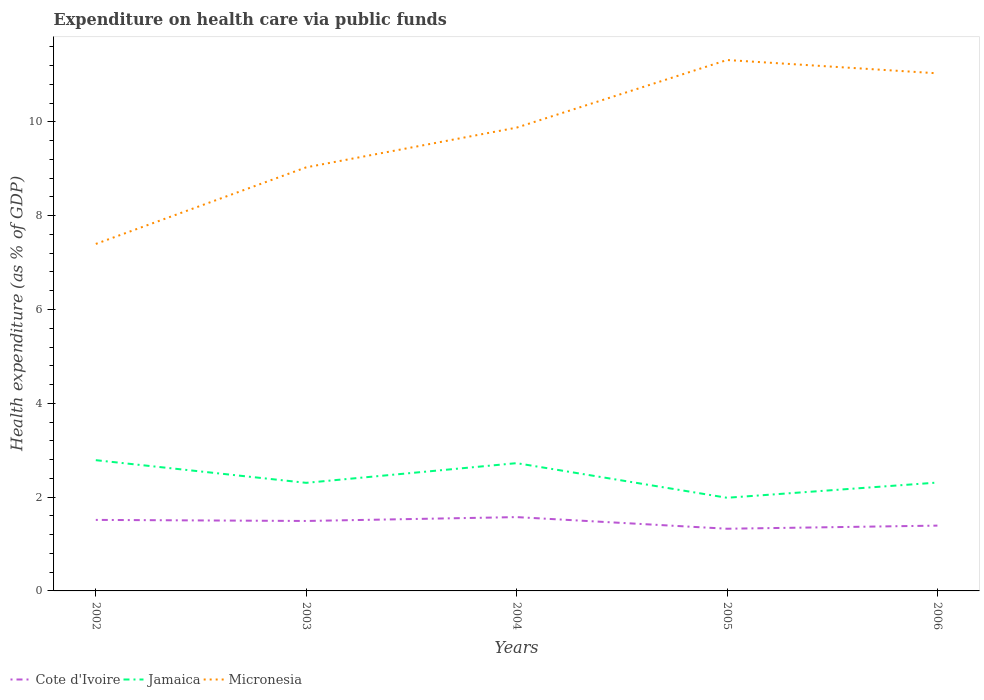Does the line corresponding to Micronesia intersect with the line corresponding to Cote d'Ivoire?
Make the answer very short. No. Across all years, what is the maximum expenditure made on health care in Jamaica?
Provide a succinct answer. 1.99. What is the total expenditure made on health care in Micronesia in the graph?
Give a very brief answer. -2. What is the difference between the highest and the second highest expenditure made on health care in Jamaica?
Give a very brief answer. 0.8. What is the difference between the highest and the lowest expenditure made on health care in Jamaica?
Give a very brief answer. 2. What is the difference between two consecutive major ticks on the Y-axis?
Keep it short and to the point. 2. Where does the legend appear in the graph?
Offer a terse response. Bottom left. What is the title of the graph?
Keep it short and to the point. Expenditure on health care via public funds. What is the label or title of the Y-axis?
Provide a short and direct response. Health expenditure (as % of GDP). What is the Health expenditure (as % of GDP) in Cote d'Ivoire in 2002?
Give a very brief answer. 1.51. What is the Health expenditure (as % of GDP) in Jamaica in 2002?
Give a very brief answer. 2.79. What is the Health expenditure (as % of GDP) in Micronesia in 2002?
Offer a very short reply. 7.4. What is the Health expenditure (as % of GDP) of Cote d'Ivoire in 2003?
Offer a terse response. 1.49. What is the Health expenditure (as % of GDP) of Jamaica in 2003?
Make the answer very short. 2.3. What is the Health expenditure (as % of GDP) in Micronesia in 2003?
Ensure brevity in your answer.  9.03. What is the Health expenditure (as % of GDP) of Cote d'Ivoire in 2004?
Provide a succinct answer. 1.57. What is the Health expenditure (as % of GDP) in Jamaica in 2004?
Give a very brief answer. 2.72. What is the Health expenditure (as % of GDP) in Micronesia in 2004?
Offer a very short reply. 9.88. What is the Health expenditure (as % of GDP) of Cote d'Ivoire in 2005?
Provide a succinct answer. 1.33. What is the Health expenditure (as % of GDP) in Jamaica in 2005?
Make the answer very short. 1.99. What is the Health expenditure (as % of GDP) in Micronesia in 2005?
Give a very brief answer. 11.32. What is the Health expenditure (as % of GDP) in Cote d'Ivoire in 2006?
Provide a succinct answer. 1.39. What is the Health expenditure (as % of GDP) of Jamaica in 2006?
Provide a short and direct response. 2.31. What is the Health expenditure (as % of GDP) in Micronesia in 2006?
Offer a terse response. 11.03. Across all years, what is the maximum Health expenditure (as % of GDP) in Cote d'Ivoire?
Give a very brief answer. 1.57. Across all years, what is the maximum Health expenditure (as % of GDP) of Jamaica?
Your response must be concise. 2.79. Across all years, what is the maximum Health expenditure (as % of GDP) in Micronesia?
Offer a terse response. 11.32. Across all years, what is the minimum Health expenditure (as % of GDP) in Cote d'Ivoire?
Keep it short and to the point. 1.33. Across all years, what is the minimum Health expenditure (as % of GDP) in Jamaica?
Give a very brief answer. 1.99. Across all years, what is the minimum Health expenditure (as % of GDP) of Micronesia?
Make the answer very short. 7.4. What is the total Health expenditure (as % of GDP) in Cote d'Ivoire in the graph?
Provide a short and direct response. 7.3. What is the total Health expenditure (as % of GDP) in Jamaica in the graph?
Your answer should be compact. 12.11. What is the total Health expenditure (as % of GDP) in Micronesia in the graph?
Keep it short and to the point. 48.66. What is the difference between the Health expenditure (as % of GDP) in Cote d'Ivoire in 2002 and that in 2003?
Keep it short and to the point. 0.02. What is the difference between the Health expenditure (as % of GDP) of Jamaica in 2002 and that in 2003?
Provide a short and direct response. 0.48. What is the difference between the Health expenditure (as % of GDP) of Micronesia in 2002 and that in 2003?
Ensure brevity in your answer.  -1.63. What is the difference between the Health expenditure (as % of GDP) in Cote d'Ivoire in 2002 and that in 2004?
Keep it short and to the point. -0.06. What is the difference between the Health expenditure (as % of GDP) of Jamaica in 2002 and that in 2004?
Provide a succinct answer. 0.06. What is the difference between the Health expenditure (as % of GDP) in Micronesia in 2002 and that in 2004?
Offer a very short reply. -2.48. What is the difference between the Health expenditure (as % of GDP) in Cote d'Ivoire in 2002 and that in 2005?
Your response must be concise. 0.19. What is the difference between the Health expenditure (as % of GDP) in Jamaica in 2002 and that in 2005?
Offer a very short reply. 0.8. What is the difference between the Health expenditure (as % of GDP) of Micronesia in 2002 and that in 2005?
Offer a very short reply. -3.92. What is the difference between the Health expenditure (as % of GDP) in Cote d'Ivoire in 2002 and that in 2006?
Make the answer very short. 0.12. What is the difference between the Health expenditure (as % of GDP) in Jamaica in 2002 and that in 2006?
Your answer should be very brief. 0.48. What is the difference between the Health expenditure (as % of GDP) of Micronesia in 2002 and that in 2006?
Offer a terse response. -3.64. What is the difference between the Health expenditure (as % of GDP) in Cote d'Ivoire in 2003 and that in 2004?
Keep it short and to the point. -0.08. What is the difference between the Health expenditure (as % of GDP) in Jamaica in 2003 and that in 2004?
Give a very brief answer. -0.42. What is the difference between the Health expenditure (as % of GDP) of Micronesia in 2003 and that in 2004?
Your answer should be very brief. -0.85. What is the difference between the Health expenditure (as % of GDP) in Cote d'Ivoire in 2003 and that in 2005?
Offer a terse response. 0.17. What is the difference between the Health expenditure (as % of GDP) in Jamaica in 2003 and that in 2005?
Provide a short and direct response. 0.32. What is the difference between the Health expenditure (as % of GDP) in Micronesia in 2003 and that in 2005?
Provide a succinct answer. -2.29. What is the difference between the Health expenditure (as % of GDP) in Cote d'Ivoire in 2003 and that in 2006?
Keep it short and to the point. 0.1. What is the difference between the Health expenditure (as % of GDP) in Jamaica in 2003 and that in 2006?
Keep it short and to the point. -0.01. What is the difference between the Health expenditure (as % of GDP) in Micronesia in 2003 and that in 2006?
Keep it short and to the point. -2. What is the difference between the Health expenditure (as % of GDP) in Cote d'Ivoire in 2004 and that in 2005?
Provide a succinct answer. 0.25. What is the difference between the Health expenditure (as % of GDP) of Jamaica in 2004 and that in 2005?
Make the answer very short. 0.74. What is the difference between the Health expenditure (as % of GDP) of Micronesia in 2004 and that in 2005?
Your response must be concise. -1.44. What is the difference between the Health expenditure (as % of GDP) in Cote d'Ivoire in 2004 and that in 2006?
Give a very brief answer. 0.18. What is the difference between the Health expenditure (as % of GDP) in Jamaica in 2004 and that in 2006?
Ensure brevity in your answer.  0.41. What is the difference between the Health expenditure (as % of GDP) in Micronesia in 2004 and that in 2006?
Offer a very short reply. -1.16. What is the difference between the Health expenditure (as % of GDP) in Cote d'Ivoire in 2005 and that in 2006?
Provide a short and direct response. -0.07. What is the difference between the Health expenditure (as % of GDP) in Jamaica in 2005 and that in 2006?
Give a very brief answer. -0.32. What is the difference between the Health expenditure (as % of GDP) of Micronesia in 2005 and that in 2006?
Provide a short and direct response. 0.28. What is the difference between the Health expenditure (as % of GDP) of Cote d'Ivoire in 2002 and the Health expenditure (as % of GDP) of Jamaica in 2003?
Keep it short and to the point. -0.79. What is the difference between the Health expenditure (as % of GDP) of Cote d'Ivoire in 2002 and the Health expenditure (as % of GDP) of Micronesia in 2003?
Ensure brevity in your answer.  -7.52. What is the difference between the Health expenditure (as % of GDP) in Jamaica in 2002 and the Health expenditure (as % of GDP) in Micronesia in 2003?
Ensure brevity in your answer.  -6.24. What is the difference between the Health expenditure (as % of GDP) of Cote d'Ivoire in 2002 and the Health expenditure (as % of GDP) of Jamaica in 2004?
Offer a very short reply. -1.21. What is the difference between the Health expenditure (as % of GDP) of Cote d'Ivoire in 2002 and the Health expenditure (as % of GDP) of Micronesia in 2004?
Offer a terse response. -8.36. What is the difference between the Health expenditure (as % of GDP) of Jamaica in 2002 and the Health expenditure (as % of GDP) of Micronesia in 2004?
Your response must be concise. -7.09. What is the difference between the Health expenditure (as % of GDP) of Cote d'Ivoire in 2002 and the Health expenditure (as % of GDP) of Jamaica in 2005?
Your answer should be compact. -0.47. What is the difference between the Health expenditure (as % of GDP) in Cote d'Ivoire in 2002 and the Health expenditure (as % of GDP) in Micronesia in 2005?
Provide a succinct answer. -9.8. What is the difference between the Health expenditure (as % of GDP) in Jamaica in 2002 and the Health expenditure (as % of GDP) in Micronesia in 2005?
Provide a short and direct response. -8.53. What is the difference between the Health expenditure (as % of GDP) in Cote d'Ivoire in 2002 and the Health expenditure (as % of GDP) in Jamaica in 2006?
Your answer should be compact. -0.8. What is the difference between the Health expenditure (as % of GDP) in Cote d'Ivoire in 2002 and the Health expenditure (as % of GDP) in Micronesia in 2006?
Provide a succinct answer. -9.52. What is the difference between the Health expenditure (as % of GDP) in Jamaica in 2002 and the Health expenditure (as % of GDP) in Micronesia in 2006?
Your answer should be very brief. -8.25. What is the difference between the Health expenditure (as % of GDP) of Cote d'Ivoire in 2003 and the Health expenditure (as % of GDP) of Jamaica in 2004?
Offer a terse response. -1.23. What is the difference between the Health expenditure (as % of GDP) of Cote d'Ivoire in 2003 and the Health expenditure (as % of GDP) of Micronesia in 2004?
Keep it short and to the point. -8.39. What is the difference between the Health expenditure (as % of GDP) in Jamaica in 2003 and the Health expenditure (as % of GDP) in Micronesia in 2004?
Provide a succinct answer. -7.57. What is the difference between the Health expenditure (as % of GDP) in Cote d'Ivoire in 2003 and the Health expenditure (as % of GDP) in Jamaica in 2005?
Provide a succinct answer. -0.49. What is the difference between the Health expenditure (as % of GDP) in Cote d'Ivoire in 2003 and the Health expenditure (as % of GDP) in Micronesia in 2005?
Your answer should be very brief. -9.83. What is the difference between the Health expenditure (as % of GDP) in Jamaica in 2003 and the Health expenditure (as % of GDP) in Micronesia in 2005?
Give a very brief answer. -9.01. What is the difference between the Health expenditure (as % of GDP) in Cote d'Ivoire in 2003 and the Health expenditure (as % of GDP) in Jamaica in 2006?
Your response must be concise. -0.82. What is the difference between the Health expenditure (as % of GDP) of Cote d'Ivoire in 2003 and the Health expenditure (as % of GDP) of Micronesia in 2006?
Give a very brief answer. -9.54. What is the difference between the Health expenditure (as % of GDP) of Jamaica in 2003 and the Health expenditure (as % of GDP) of Micronesia in 2006?
Keep it short and to the point. -8.73. What is the difference between the Health expenditure (as % of GDP) in Cote d'Ivoire in 2004 and the Health expenditure (as % of GDP) in Jamaica in 2005?
Keep it short and to the point. -0.41. What is the difference between the Health expenditure (as % of GDP) in Cote d'Ivoire in 2004 and the Health expenditure (as % of GDP) in Micronesia in 2005?
Your answer should be very brief. -9.74. What is the difference between the Health expenditure (as % of GDP) of Jamaica in 2004 and the Health expenditure (as % of GDP) of Micronesia in 2005?
Give a very brief answer. -8.59. What is the difference between the Health expenditure (as % of GDP) in Cote d'Ivoire in 2004 and the Health expenditure (as % of GDP) in Jamaica in 2006?
Offer a very short reply. -0.74. What is the difference between the Health expenditure (as % of GDP) of Cote d'Ivoire in 2004 and the Health expenditure (as % of GDP) of Micronesia in 2006?
Provide a succinct answer. -9.46. What is the difference between the Health expenditure (as % of GDP) in Jamaica in 2004 and the Health expenditure (as % of GDP) in Micronesia in 2006?
Your answer should be compact. -8.31. What is the difference between the Health expenditure (as % of GDP) of Cote d'Ivoire in 2005 and the Health expenditure (as % of GDP) of Jamaica in 2006?
Give a very brief answer. -0.98. What is the difference between the Health expenditure (as % of GDP) of Cote d'Ivoire in 2005 and the Health expenditure (as % of GDP) of Micronesia in 2006?
Offer a terse response. -9.71. What is the difference between the Health expenditure (as % of GDP) of Jamaica in 2005 and the Health expenditure (as % of GDP) of Micronesia in 2006?
Give a very brief answer. -9.05. What is the average Health expenditure (as % of GDP) in Cote d'Ivoire per year?
Your answer should be very brief. 1.46. What is the average Health expenditure (as % of GDP) of Jamaica per year?
Your answer should be compact. 2.42. What is the average Health expenditure (as % of GDP) in Micronesia per year?
Your answer should be compact. 9.73. In the year 2002, what is the difference between the Health expenditure (as % of GDP) of Cote d'Ivoire and Health expenditure (as % of GDP) of Jamaica?
Your answer should be compact. -1.27. In the year 2002, what is the difference between the Health expenditure (as % of GDP) of Cote d'Ivoire and Health expenditure (as % of GDP) of Micronesia?
Offer a very short reply. -5.88. In the year 2002, what is the difference between the Health expenditure (as % of GDP) of Jamaica and Health expenditure (as % of GDP) of Micronesia?
Keep it short and to the point. -4.61. In the year 2003, what is the difference between the Health expenditure (as % of GDP) in Cote d'Ivoire and Health expenditure (as % of GDP) in Jamaica?
Offer a terse response. -0.81. In the year 2003, what is the difference between the Health expenditure (as % of GDP) of Cote d'Ivoire and Health expenditure (as % of GDP) of Micronesia?
Offer a terse response. -7.54. In the year 2003, what is the difference between the Health expenditure (as % of GDP) of Jamaica and Health expenditure (as % of GDP) of Micronesia?
Ensure brevity in your answer.  -6.73. In the year 2004, what is the difference between the Health expenditure (as % of GDP) in Cote d'Ivoire and Health expenditure (as % of GDP) in Jamaica?
Give a very brief answer. -1.15. In the year 2004, what is the difference between the Health expenditure (as % of GDP) in Cote d'Ivoire and Health expenditure (as % of GDP) in Micronesia?
Give a very brief answer. -8.3. In the year 2004, what is the difference between the Health expenditure (as % of GDP) of Jamaica and Health expenditure (as % of GDP) of Micronesia?
Your answer should be compact. -7.15. In the year 2005, what is the difference between the Health expenditure (as % of GDP) of Cote d'Ivoire and Health expenditure (as % of GDP) of Jamaica?
Your answer should be compact. -0.66. In the year 2005, what is the difference between the Health expenditure (as % of GDP) of Cote d'Ivoire and Health expenditure (as % of GDP) of Micronesia?
Keep it short and to the point. -9.99. In the year 2005, what is the difference between the Health expenditure (as % of GDP) of Jamaica and Health expenditure (as % of GDP) of Micronesia?
Keep it short and to the point. -9.33. In the year 2006, what is the difference between the Health expenditure (as % of GDP) of Cote d'Ivoire and Health expenditure (as % of GDP) of Jamaica?
Your answer should be very brief. -0.92. In the year 2006, what is the difference between the Health expenditure (as % of GDP) of Cote d'Ivoire and Health expenditure (as % of GDP) of Micronesia?
Offer a terse response. -9.64. In the year 2006, what is the difference between the Health expenditure (as % of GDP) in Jamaica and Health expenditure (as % of GDP) in Micronesia?
Give a very brief answer. -8.72. What is the ratio of the Health expenditure (as % of GDP) of Cote d'Ivoire in 2002 to that in 2003?
Make the answer very short. 1.02. What is the ratio of the Health expenditure (as % of GDP) of Jamaica in 2002 to that in 2003?
Your response must be concise. 1.21. What is the ratio of the Health expenditure (as % of GDP) of Micronesia in 2002 to that in 2003?
Give a very brief answer. 0.82. What is the ratio of the Health expenditure (as % of GDP) of Cote d'Ivoire in 2002 to that in 2004?
Ensure brevity in your answer.  0.96. What is the ratio of the Health expenditure (as % of GDP) in Jamaica in 2002 to that in 2004?
Your answer should be compact. 1.02. What is the ratio of the Health expenditure (as % of GDP) of Micronesia in 2002 to that in 2004?
Your answer should be compact. 0.75. What is the ratio of the Health expenditure (as % of GDP) in Cote d'Ivoire in 2002 to that in 2005?
Offer a terse response. 1.14. What is the ratio of the Health expenditure (as % of GDP) in Jamaica in 2002 to that in 2005?
Offer a terse response. 1.4. What is the ratio of the Health expenditure (as % of GDP) of Micronesia in 2002 to that in 2005?
Keep it short and to the point. 0.65. What is the ratio of the Health expenditure (as % of GDP) of Cote d'Ivoire in 2002 to that in 2006?
Give a very brief answer. 1.09. What is the ratio of the Health expenditure (as % of GDP) in Jamaica in 2002 to that in 2006?
Your response must be concise. 1.21. What is the ratio of the Health expenditure (as % of GDP) in Micronesia in 2002 to that in 2006?
Provide a succinct answer. 0.67. What is the ratio of the Health expenditure (as % of GDP) of Cote d'Ivoire in 2003 to that in 2004?
Provide a short and direct response. 0.95. What is the ratio of the Health expenditure (as % of GDP) in Jamaica in 2003 to that in 2004?
Give a very brief answer. 0.85. What is the ratio of the Health expenditure (as % of GDP) in Micronesia in 2003 to that in 2004?
Make the answer very short. 0.91. What is the ratio of the Health expenditure (as % of GDP) of Cote d'Ivoire in 2003 to that in 2005?
Your response must be concise. 1.12. What is the ratio of the Health expenditure (as % of GDP) of Jamaica in 2003 to that in 2005?
Offer a very short reply. 1.16. What is the ratio of the Health expenditure (as % of GDP) of Micronesia in 2003 to that in 2005?
Your answer should be very brief. 0.8. What is the ratio of the Health expenditure (as % of GDP) in Cote d'Ivoire in 2003 to that in 2006?
Give a very brief answer. 1.07. What is the ratio of the Health expenditure (as % of GDP) of Jamaica in 2003 to that in 2006?
Your answer should be compact. 1. What is the ratio of the Health expenditure (as % of GDP) in Micronesia in 2003 to that in 2006?
Make the answer very short. 0.82. What is the ratio of the Health expenditure (as % of GDP) in Cote d'Ivoire in 2004 to that in 2005?
Ensure brevity in your answer.  1.19. What is the ratio of the Health expenditure (as % of GDP) of Jamaica in 2004 to that in 2005?
Give a very brief answer. 1.37. What is the ratio of the Health expenditure (as % of GDP) in Micronesia in 2004 to that in 2005?
Your answer should be compact. 0.87. What is the ratio of the Health expenditure (as % of GDP) in Cote d'Ivoire in 2004 to that in 2006?
Offer a terse response. 1.13. What is the ratio of the Health expenditure (as % of GDP) in Jamaica in 2004 to that in 2006?
Give a very brief answer. 1.18. What is the ratio of the Health expenditure (as % of GDP) of Micronesia in 2004 to that in 2006?
Ensure brevity in your answer.  0.9. What is the ratio of the Health expenditure (as % of GDP) of Cote d'Ivoire in 2005 to that in 2006?
Your response must be concise. 0.95. What is the ratio of the Health expenditure (as % of GDP) of Jamaica in 2005 to that in 2006?
Your answer should be compact. 0.86. What is the ratio of the Health expenditure (as % of GDP) of Micronesia in 2005 to that in 2006?
Give a very brief answer. 1.03. What is the difference between the highest and the second highest Health expenditure (as % of GDP) of Cote d'Ivoire?
Give a very brief answer. 0.06. What is the difference between the highest and the second highest Health expenditure (as % of GDP) in Jamaica?
Your response must be concise. 0.06. What is the difference between the highest and the second highest Health expenditure (as % of GDP) of Micronesia?
Offer a terse response. 0.28. What is the difference between the highest and the lowest Health expenditure (as % of GDP) in Cote d'Ivoire?
Ensure brevity in your answer.  0.25. What is the difference between the highest and the lowest Health expenditure (as % of GDP) of Jamaica?
Keep it short and to the point. 0.8. What is the difference between the highest and the lowest Health expenditure (as % of GDP) in Micronesia?
Provide a succinct answer. 3.92. 